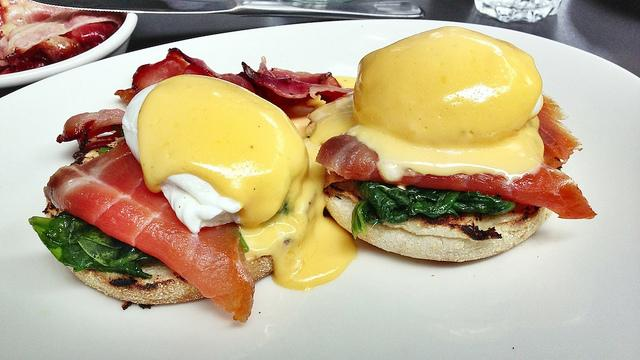What type of egg dish is shown? Please explain your reasoning. benedict. Only one of the choices are eggs that have hollandaise sauce. 